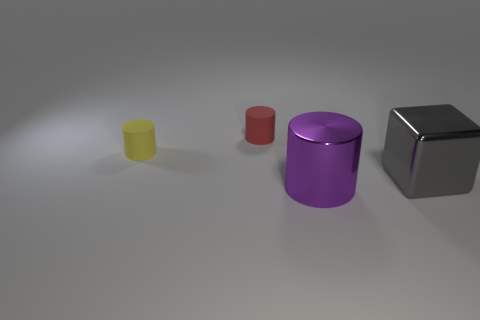Subtract all purple cylinders. How many cylinders are left? 2 Add 3 small red objects. How many objects exist? 7 Subtract all purple cylinders. How many cylinders are left? 2 Subtract all cylinders. How many objects are left? 1 Subtract all green matte cylinders. Subtract all small things. How many objects are left? 2 Add 4 large metallic blocks. How many large metallic blocks are left? 5 Add 3 big shiny balls. How many big shiny balls exist? 3 Subtract 1 yellow cylinders. How many objects are left? 3 Subtract all green cylinders. Subtract all blue spheres. How many cylinders are left? 3 